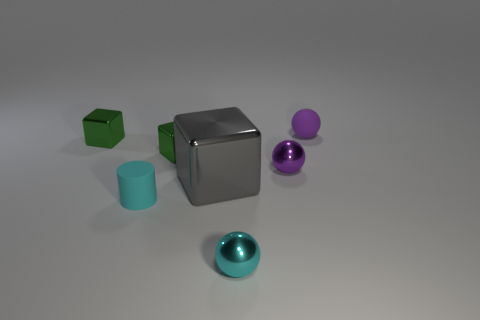Subtract all small green blocks. How many blocks are left? 1 Subtract all green cubes. How many cubes are left? 1 Subtract 2 balls. How many balls are left? 1 Subtract all brown blocks. Subtract all purple balls. How many blocks are left? 3 Subtract all brown cubes. How many gray cylinders are left? 0 Add 6 purple balls. How many purple balls exist? 8 Add 1 purple metal objects. How many objects exist? 8 Subtract 0 gray balls. How many objects are left? 7 Subtract all spheres. How many objects are left? 4 Subtract all tiny green metallic objects. Subtract all purple things. How many objects are left? 3 